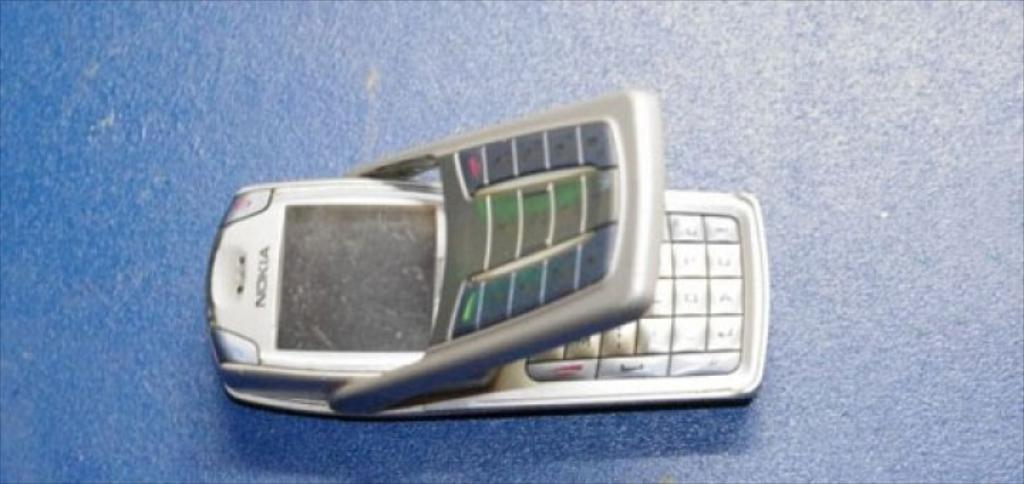<image>
Share a concise interpretation of the image provided. a Nokia flip cell phone is on a blue surface 